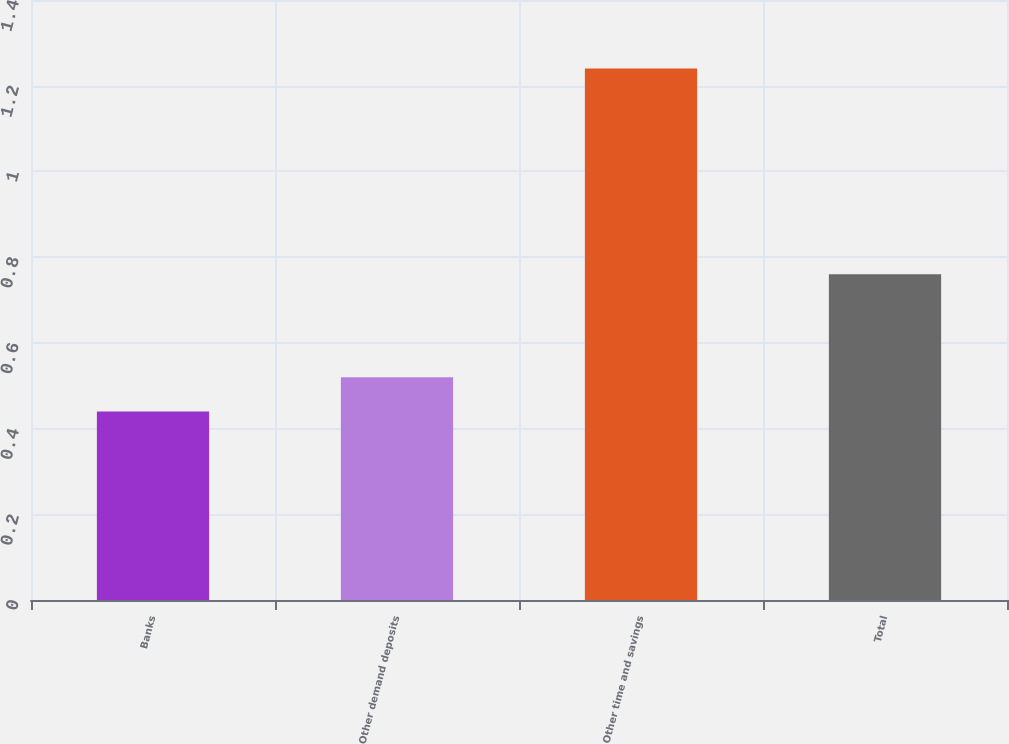Convert chart to OTSL. <chart><loc_0><loc_0><loc_500><loc_500><bar_chart><fcel>Banks<fcel>Other demand deposits<fcel>Other time and savings<fcel>Total<nl><fcel>0.44<fcel>0.52<fcel>1.24<fcel>0.76<nl></chart> 